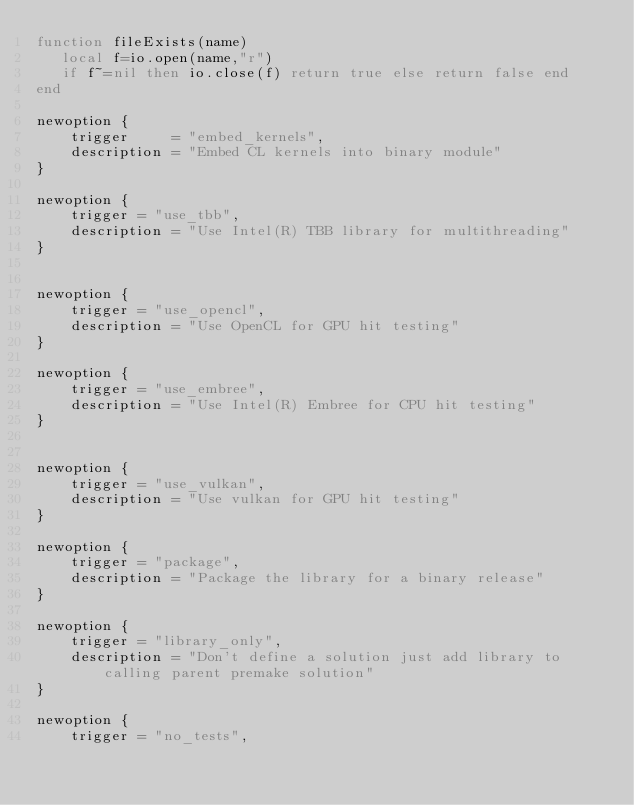<code> <loc_0><loc_0><loc_500><loc_500><_Lua_>function fileExists(name)
   local f=io.open(name,"r")
   if f~=nil then io.close(f) return true else return false end
end

newoption {
    trigger     = "embed_kernels",
    description = "Embed CL kernels into binary module"
}

newoption {
    trigger = "use_tbb",
    description = "Use Intel(R) TBB library for multithreading"
}


newoption {
    trigger = "use_opencl",
    description = "Use OpenCL for GPU hit testing"
}

newoption {
    trigger = "use_embree",
    description = "Use Intel(R) Embree for CPU hit testing"
}


newoption {
    trigger = "use_vulkan",
    description = "Use vulkan for GPU hit testing"
}

newoption {
    trigger = "package",
    description = "Package the library for a binary release"
}

newoption {
    trigger = "library_only",
    description = "Don't define a solution just add library to calling parent premake solution"
}

newoption {
    trigger = "no_tests",</code> 